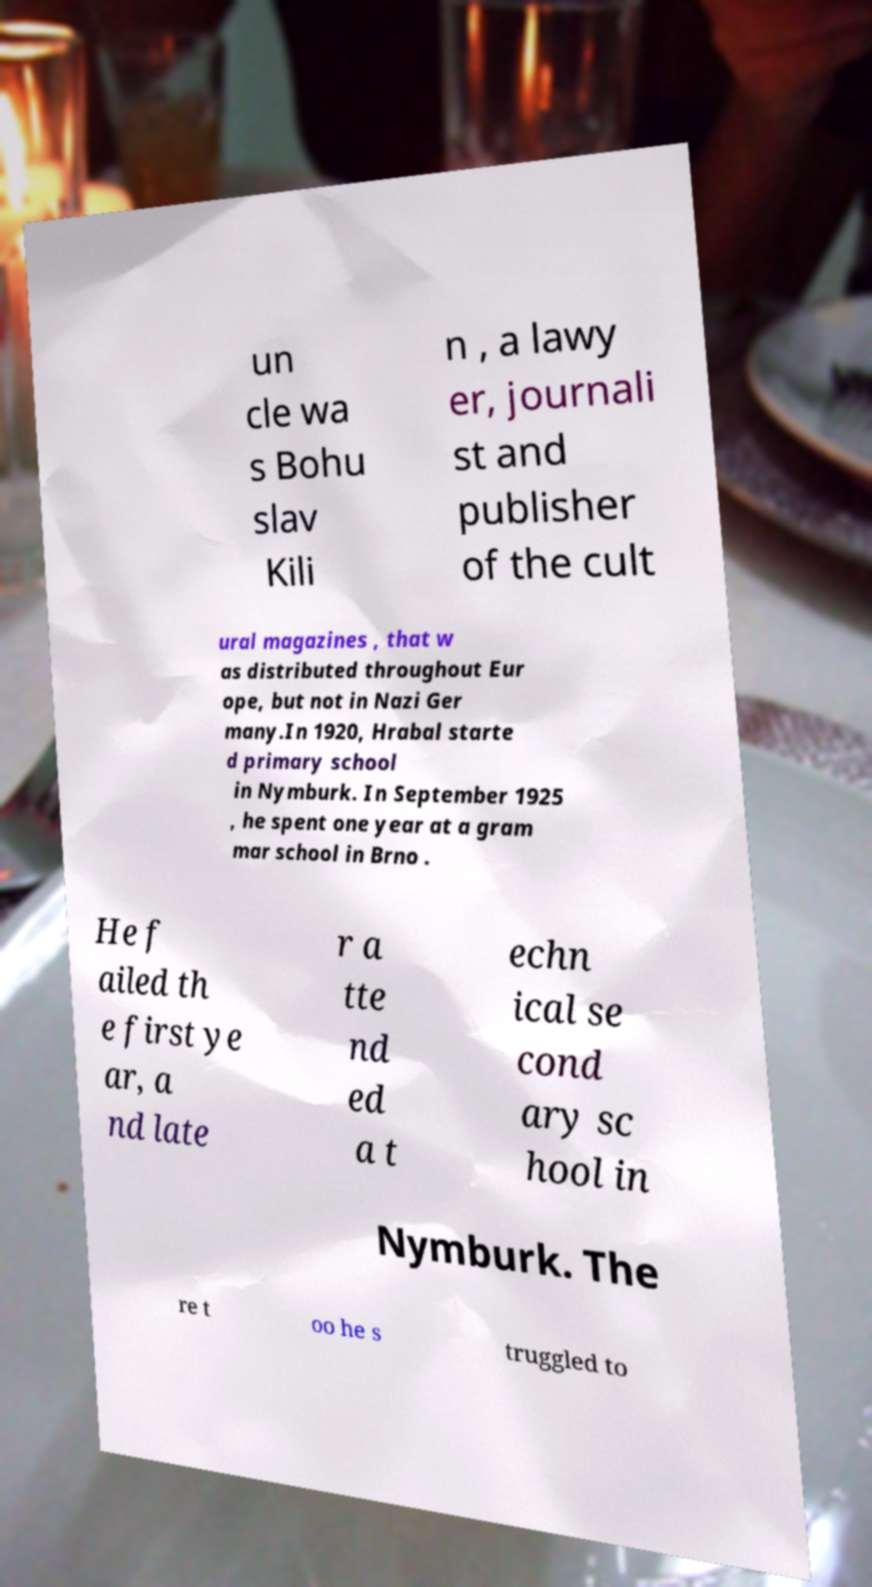What messages or text are displayed in this image? I need them in a readable, typed format. un cle wa s Bohu slav Kili n , a lawy er, journali st and publisher of the cult ural magazines , that w as distributed throughout Eur ope, but not in Nazi Ger many.In 1920, Hrabal starte d primary school in Nymburk. In September 1925 , he spent one year at a gram mar school in Brno . He f ailed th e first ye ar, a nd late r a tte nd ed a t echn ical se cond ary sc hool in Nymburk. The re t oo he s truggled to 